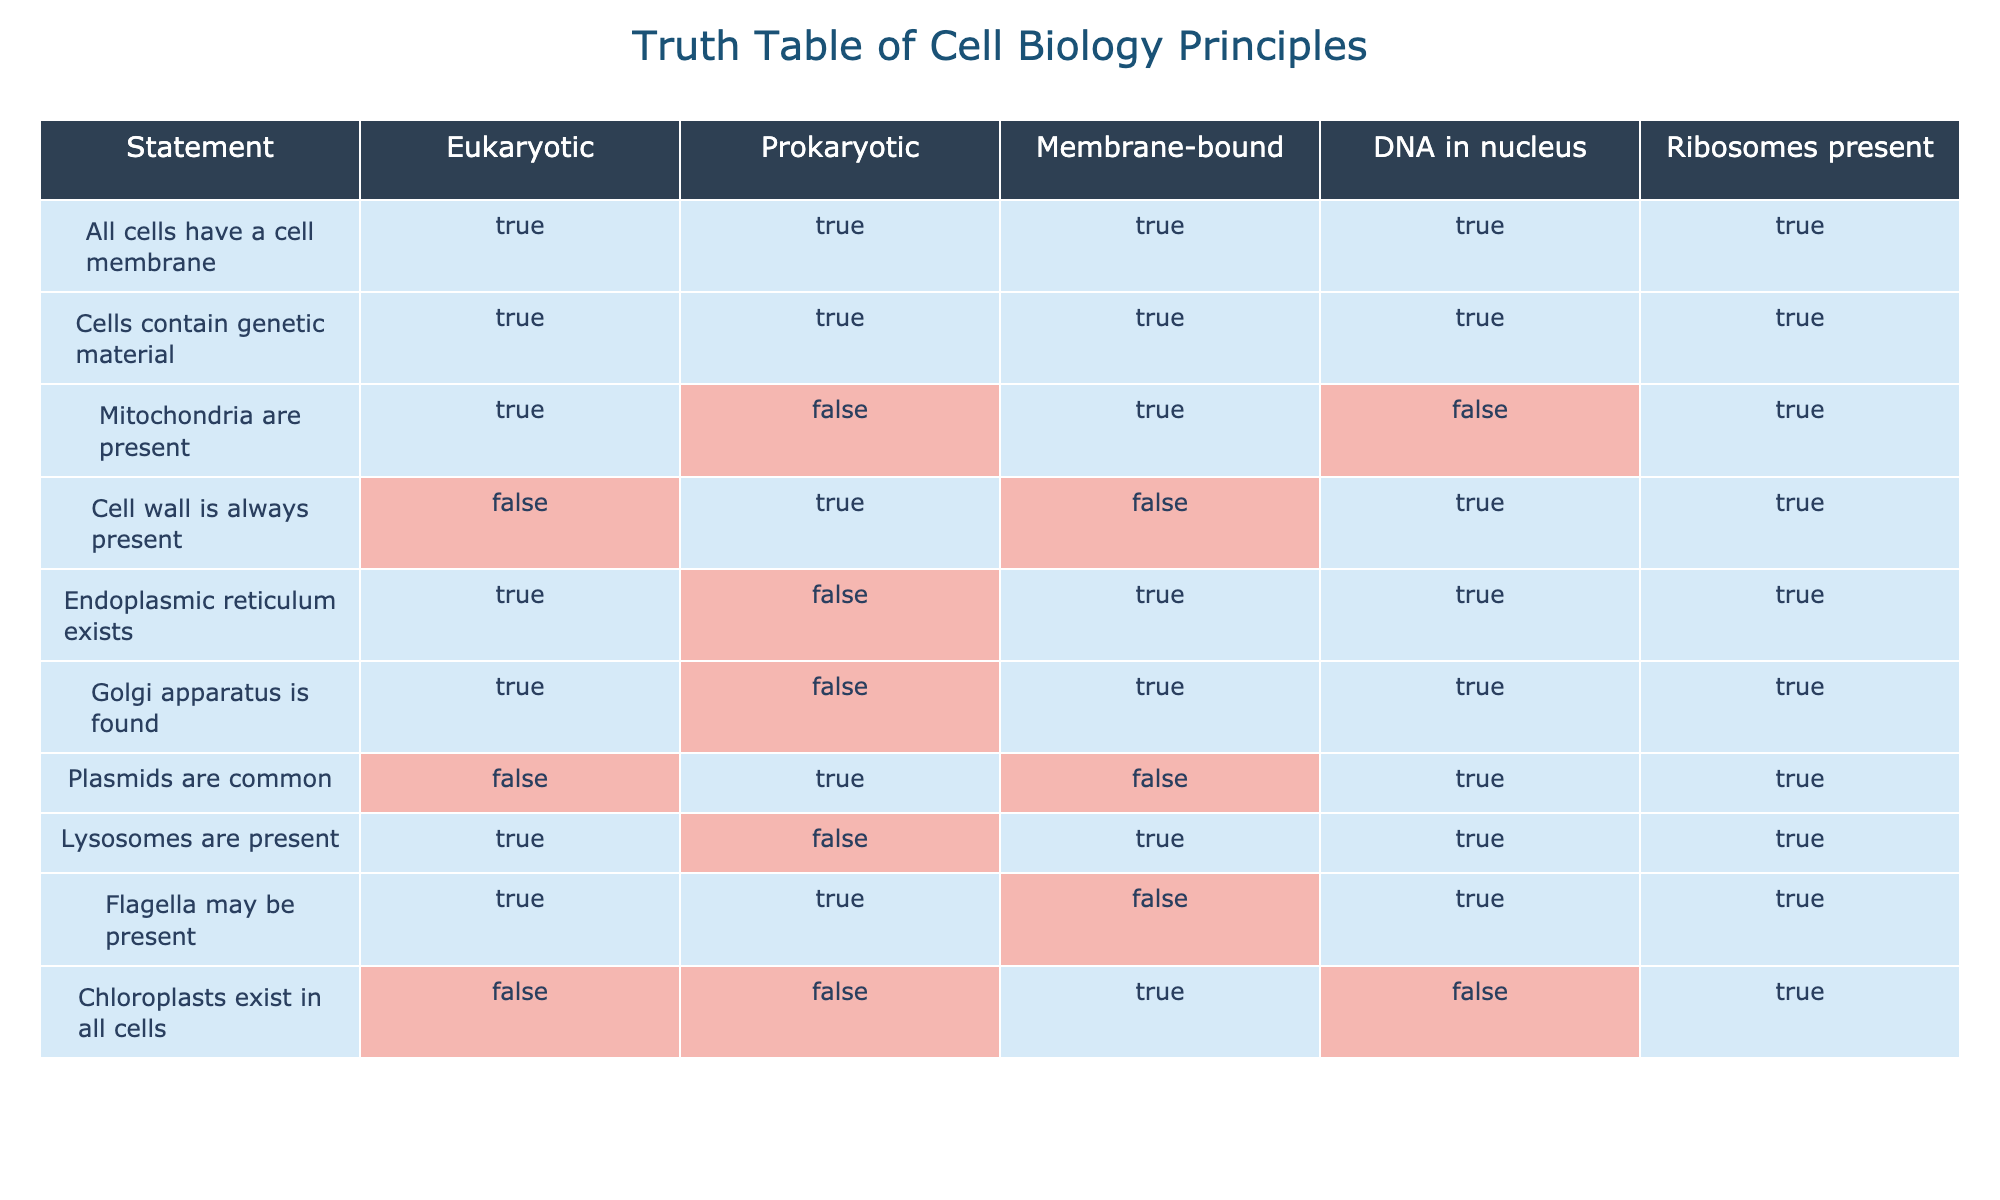What is true for all types of cells regarding cell membranes? The table shows that the statement "All cells have a cell membrane" is marked TRUE for both Eukaryotic and Prokaryotic cells. This means it is a universally accepted concept that all types of cells possess a cell membrane.
Answer: TRUE Do cells have genetic material? The statement "Cells contain genetic material" is listed as TRUE for all categories: Eukaryotic, Prokaryotic, Membrane-bound, DNA in nucleus, and Ribosomes present. This indicates that all cells indeed contain genetic material.
Answer: TRUE How many statements indicate that mitochondria are present in cells? Only the statement "Mitochondria are present" indicates that this organelle is found in Eukaryotic cells (TRUE), while it is marked FALSE for Prokaryotic cells. Thus, there is only one statement reflecting the presence of mitochondria.
Answer: 1 Which type of cell does not always have a cell wall? The table states that "Cell wall is always present" is FALSE for Eukaryotic cells (TRUE for Prokaryotic cells). This means that not all Eukaryotic cells have a cell wall, especially in the case of animal cells.
Answer: Eukaryotic What is the relationship between ribosomes and the presence of lysosomes? The table shows that "Lysosomes are present" is TRUE for Eukaryotic cells and FALSE for Prokaryotic cells, while "Ribosomes are present" is TRUE for both categories. This implies that ribosomes can be present regardless of the presence of lysosomes since lysosomes exist only in Eukaryotic cells.
Answer: Ribosomes are present regardless of lysosome presence How many organelles are exclusive to Eukaryotic cells in this table? The organelles only found in Eukaryotic cells according to the table are mitochondria, endoplasmic reticulum, Golgi apparatus, and lysosomes. Therefore, there are four organelles exclusively present in Eukaryotic cells.
Answer: 4 Is it true that plasmids are present in eukaryotic cells? The statement "Plasmids are common" is listed as FALSE for Eukaryotic cells according to the table. Hence, plasmids are not considered common in Eukaryotic cells.
Answer: FALSE Are chloroplasts found in prokaryotic cells? The table mentions that "Chloroplasts exist in all cells" is marked FALSE for both Eukaryotic and Prokaryotic cells. Therefore, chloroplasts are not found in Prokaryotic cells.
Answer: FALSE What proportion of Eukaryotic cells contain a Golgi apparatus? The statement about the Golgi apparatus indicates TRUE for Eukaryotic cells. Since there is only one type or proportion of Eukaryotic cells considered here, we can say 100% of Eukaryotic cells contain a Golgi apparatus as per the data in this context.
Answer: 100% 